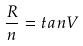<formula> <loc_0><loc_0><loc_500><loc_500>\frac { R } { n } = t a n V</formula> 